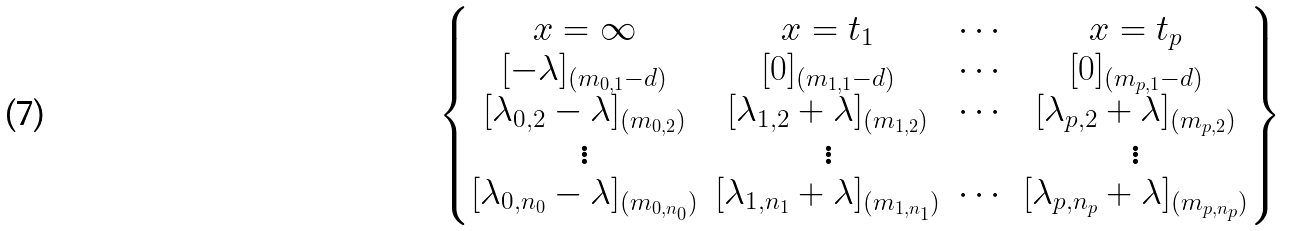Convert formula to latex. <formula><loc_0><loc_0><loc_500><loc_500>\begin{Bmatrix} x = \infty & x = t _ { 1 } & \cdots & x = t _ { p } \\ [ - \lambda ] _ { ( m _ { 0 , 1 } - d ) } & [ 0 ] _ { ( m _ { 1 , 1 } - d ) } & \cdots & [ 0 ] _ { ( m _ { p , 1 } - d ) } \\ [ \lambda _ { 0 , 2 } - \lambda ] _ { ( m _ { 0 , 2 } ) } & [ \lambda _ { 1 , 2 } + \lambda ] _ { ( m _ { 1 , 2 } ) } & \cdots & [ \lambda _ { p , 2 } + \lambda ] _ { ( m _ { p , 2 } ) } \\ \vdots & \vdots & & \vdots \\ [ \lambda _ { 0 , n _ { 0 } } - \lambda ] _ { ( m _ { 0 , n _ { 0 } } ) } & [ \lambda _ { 1 , n _ { 1 } } + \lambda ] _ { ( m _ { 1 , n _ { 1 } } ) } & \cdots & [ \lambda _ { p , n _ { p } } + \lambda ] _ { ( m _ { p , n _ { p } } ) } \end{Bmatrix}</formula> 